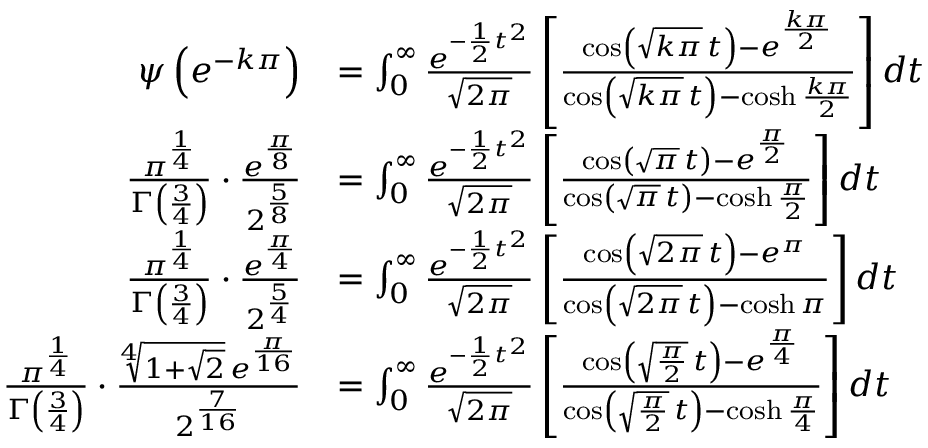<formula> <loc_0><loc_0><loc_500><loc_500>{ \begin{array} { r l } { \psi \left ( e ^ { - k \pi } \right ) } & { = \int _ { 0 } ^ { \infty } { \frac { e ^ { - { \frac { 1 } { 2 } } t ^ { 2 } } } { \sqrt { 2 \pi } } } \left [ { \frac { \cos \left ( { \sqrt { k \pi } } \, t \right ) - e ^ { \frac { k \pi } { 2 } } } { \cos \left ( { \sqrt { k \pi } } \, t \right ) - \cosh { \frac { k \pi } { 2 } } } } \right ] d t } \\ { { \frac { \pi ^ { \frac { 1 } { 4 } } } { \Gamma \left ( { \frac { 3 } { 4 } } \right ) } } \cdot { \frac { e ^ { \frac { \pi } { 8 } } } { 2 ^ { \frac { 5 } { 8 } } } } } & { = \int _ { 0 } ^ { \infty } { \frac { e ^ { - { \frac { 1 } { 2 } } t ^ { 2 } } } { \sqrt { 2 \pi } } } \left [ { \frac { \cos \left ( { \sqrt { \pi } } \, t \right ) - e ^ { \frac { \pi } { 2 } } } { \cos \left ( { \sqrt { \pi } } \, t \right ) - \cosh { \frac { \pi } { 2 } } } } \right ] d t } \\ { { \frac { \pi ^ { \frac { 1 } { 4 } } } { \Gamma \left ( { \frac { 3 } { 4 } } \right ) } } \cdot { \frac { e ^ { \frac { \pi } { 4 } } } { 2 ^ { \frac { 5 } { 4 } } } } } & { = \int _ { 0 } ^ { \infty } { \frac { e ^ { - { \frac { 1 } { 2 } } t ^ { 2 } } } { \sqrt { 2 \pi } } } \left [ { \frac { \cos \left ( { \sqrt { 2 \pi } } \, t \right ) - e ^ { \pi } } { \cos \left ( { \sqrt { 2 \pi } } \, t \right ) - \cosh \pi } } \right ] d t } \\ { { \frac { \pi ^ { \frac { 1 } { 4 } } } { \Gamma \left ( { \frac { 3 } { 4 } } \right ) } } \cdot { \frac { { \sqrt { [ } { 4 } ] { 1 + { \sqrt { 2 } } } } \, e ^ { \frac { \pi } { 1 6 } } } { 2 ^ { \frac { 7 } { 1 6 } } } } } & { = \int _ { 0 } ^ { \infty } { \frac { e ^ { - { \frac { 1 } { 2 } } t ^ { 2 } } } { \sqrt { 2 \pi } } } \left [ { \frac { \cos \left ( { \sqrt { \frac { \pi } { 2 } } } \, t \right ) - e ^ { \frac { \pi } { 4 } } } { \cos \left ( { \sqrt { \frac { \pi } { 2 } } } \, t \right ) - \cosh { \frac { \pi } { 4 } } } } \right ] d t } \end{array} }</formula> 